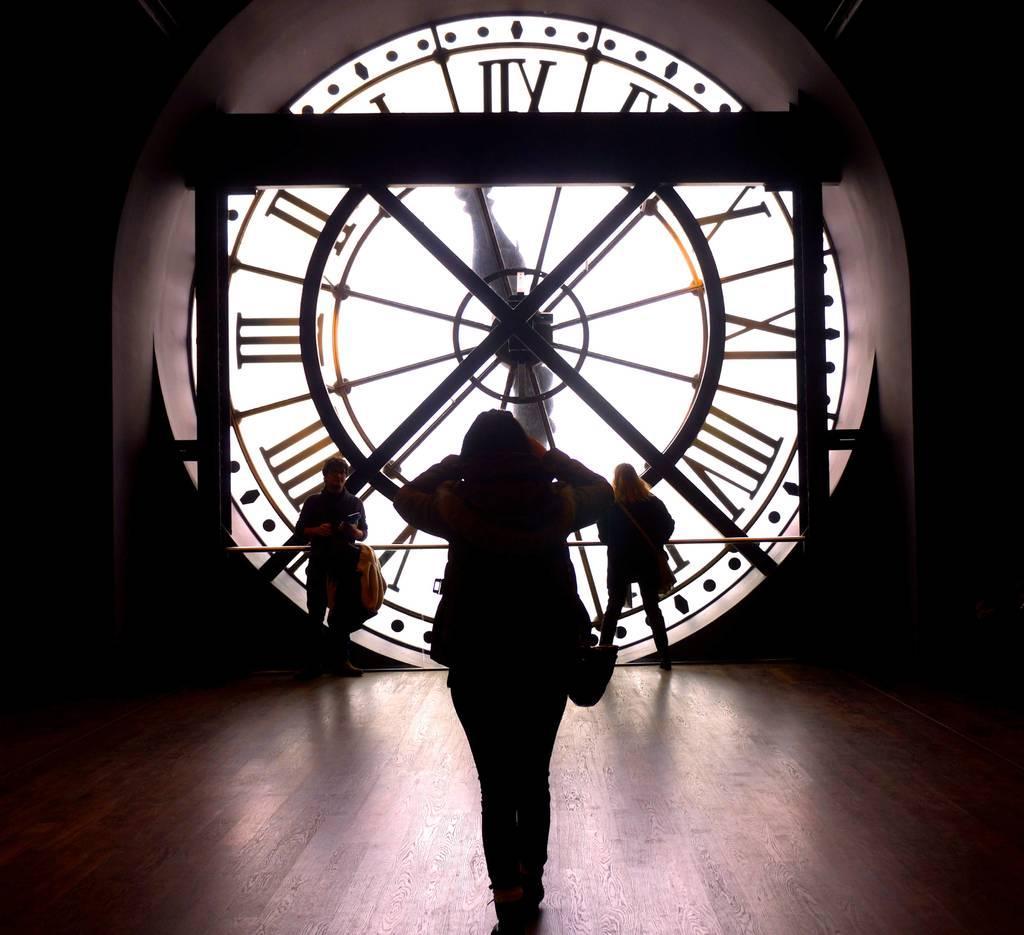How would you summarize this image in a sentence or two? In this image we can see some group of persons walking some are carrying bags and in the background of the image we can see clock. 